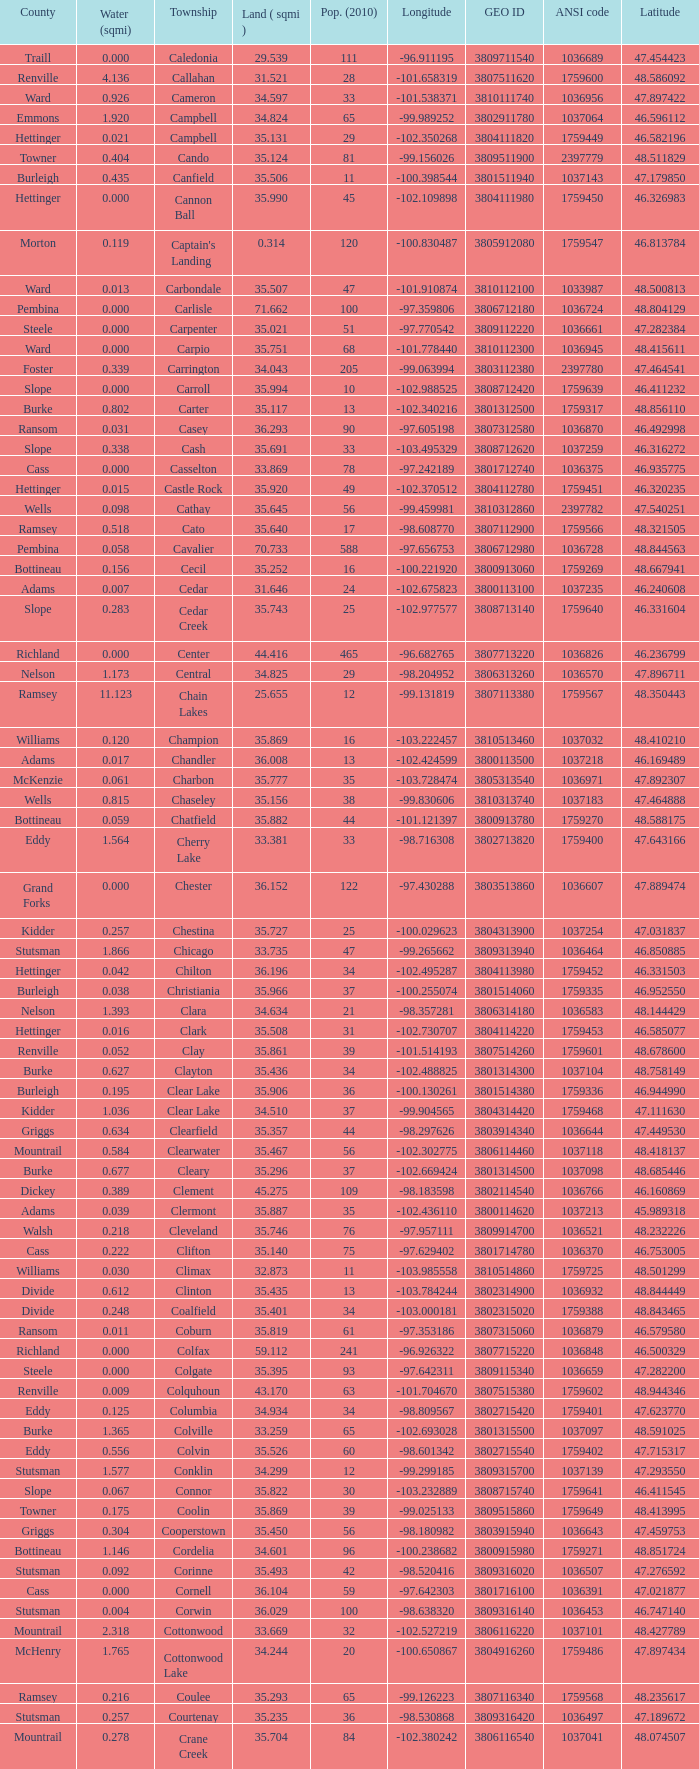What was the township with a geo ID of 3807116660? Creel. 